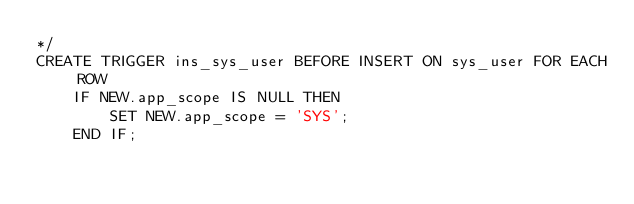Convert code to text. <code><loc_0><loc_0><loc_500><loc_500><_SQL_>*/
CREATE TRIGGER ins_sys_user BEFORE INSERT ON sys_user FOR EACH ROW
    IF NEW.app_scope IS NULL THEN
        SET NEW.app_scope = 'SYS';
    END IF;</code> 